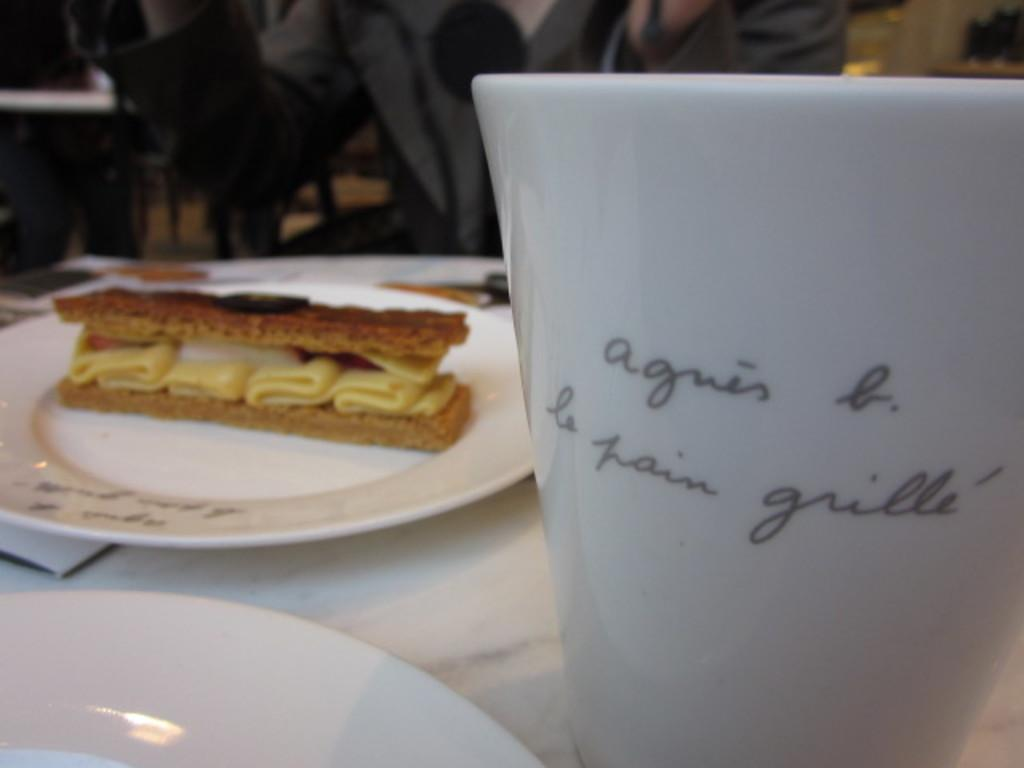What objects are on the surface in the image? There are plates and a glass on the surface. What can be seen on the plates and glass? Something is written on the plate and glass. What is on the plate that is not written? There is a food item on the plate. Can you describe the person in the background? There is a person sitting in the background. What type of plantation can be seen in the image? There is no plantation present in the image. What activity is taking place during the recess in the image? The image does not depict a recess or any specific activity related to it. 